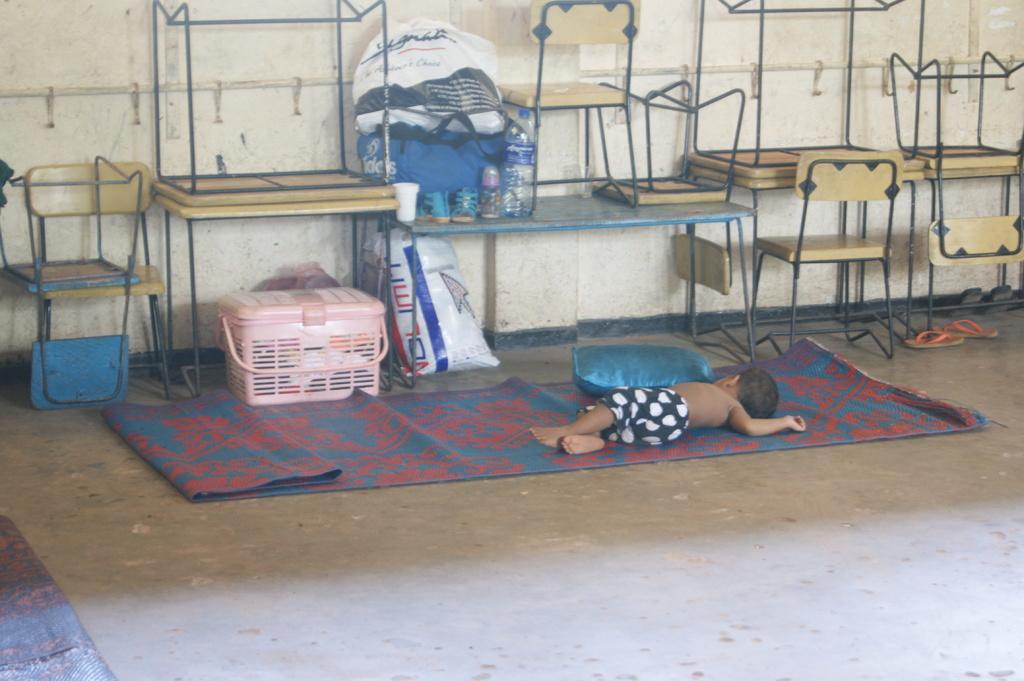Could you give a brief overview of what you see in this image? In the center of the image we can see pillow and baby sleeping on the mat. In the background benches, chairs, containers, covers, bottles, slippers and wall. 